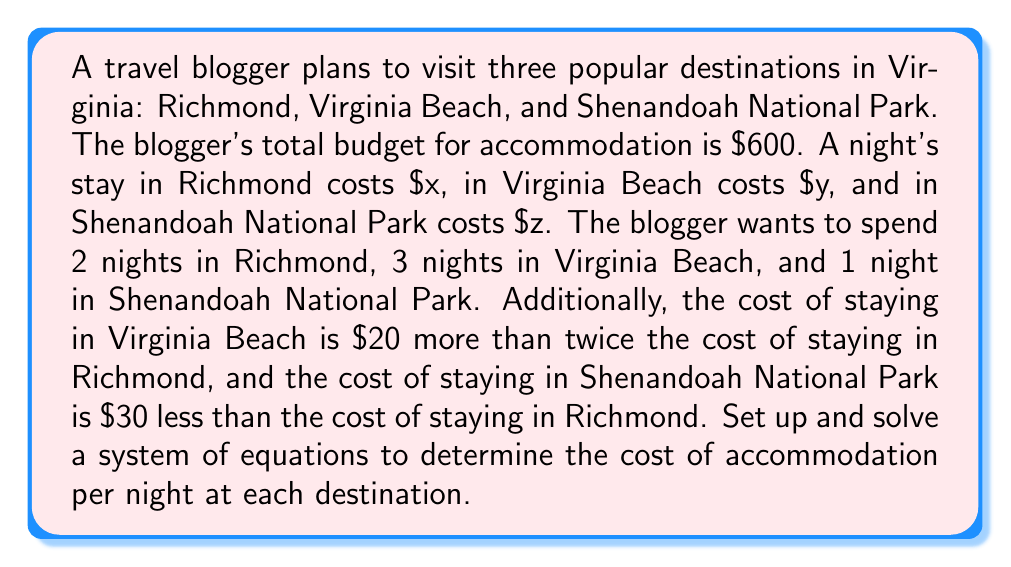What is the answer to this math problem? Let's approach this step-by-step:

1) First, let's define our variables:
   $x$ = cost per night in Richmond
   $y$ = cost per night in Virginia Beach
   $z$ = cost per night in Shenandoah National Park

2) Now, let's set up our system of equations based on the given information:

   Equation 1 (total budget): $2x + 3y + z = 600$
   Equation 2 (Virginia Beach cost): $y = 2x + 20$
   Equation 3 (Shenandoah cost): $z = x - 30$

3) Let's substitute Equations 2 and 3 into Equation 1:

   $2x + 3(2x + 20) + (x - 30) = 600$

4) Simplify:

   $2x + 6x + 60 + x - 30 = 600$
   $9x + 30 = 600$

5) Solve for $x$:

   $9x = 570$
   $x = 570/9 = 63.33$

6) Now that we know $x$, we can find $y$ and $z$:

   $y = 2(63.33) + 20 = 146.66$
   $z = 63.33 - 30 = 33.33$

7) Let's round to the nearest dollar for practicality:

   $x = 63$ (Richmond)
   $y = 147$ (Virginia Beach)
   $z = 33$ (Shenandoah National Park)
Answer: Richmond: $63/night, Virginia Beach: $147/night, Shenandoah National Park: $33/night 